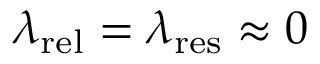<formula> <loc_0><loc_0><loc_500><loc_500>\lambda _ { r e l } = \lambda _ { r e s } \approx 0</formula> 